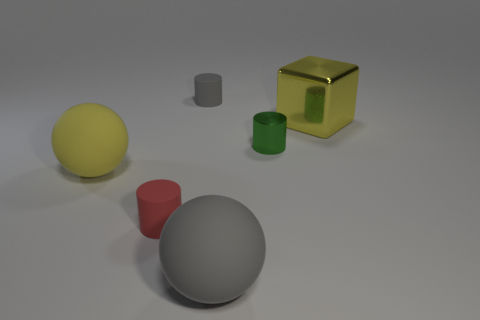Add 3 small shiny cylinders. How many objects exist? 9 Subtract all balls. How many objects are left? 4 Subtract all brown cubes. Subtract all yellow objects. How many objects are left? 4 Add 4 red cylinders. How many red cylinders are left? 5 Add 6 big cyan shiny things. How many big cyan shiny things exist? 6 Subtract 1 gray cylinders. How many objects are left? 5 